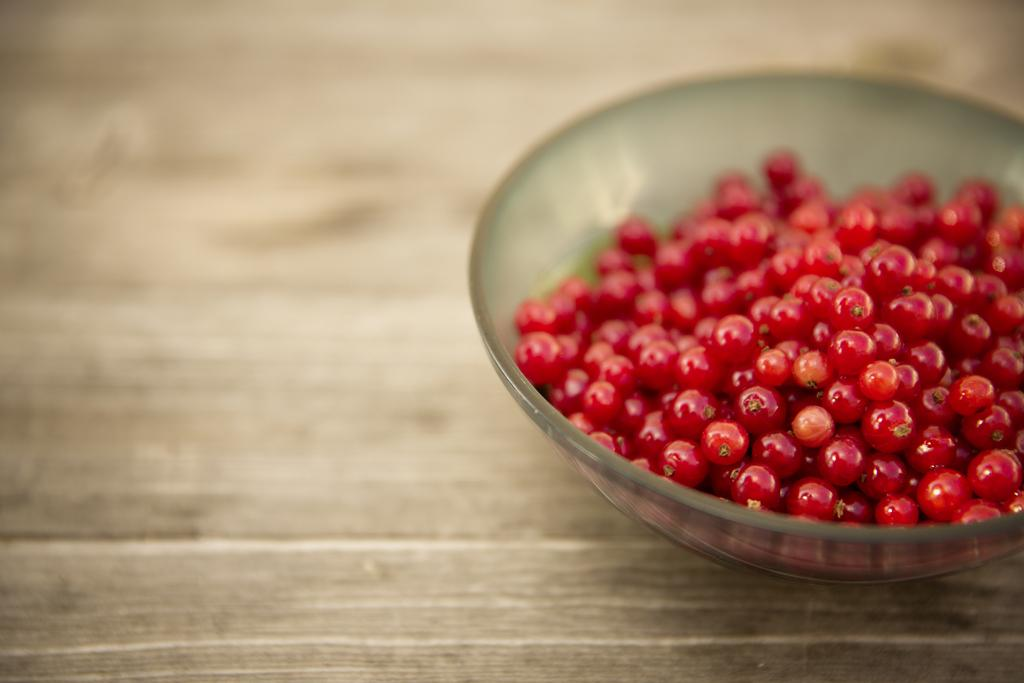What is in the bowl that is visible in the image? The bowl contains red food items, likely berries. Where is the bowl located in the image? The bowl is placed on a wooden table. What time of day is it in the image, and is there a duck present? The time of day cannot be determined from the image, and there is no duck present. Can you see a brush in the image? There is no brush visible in the image. 